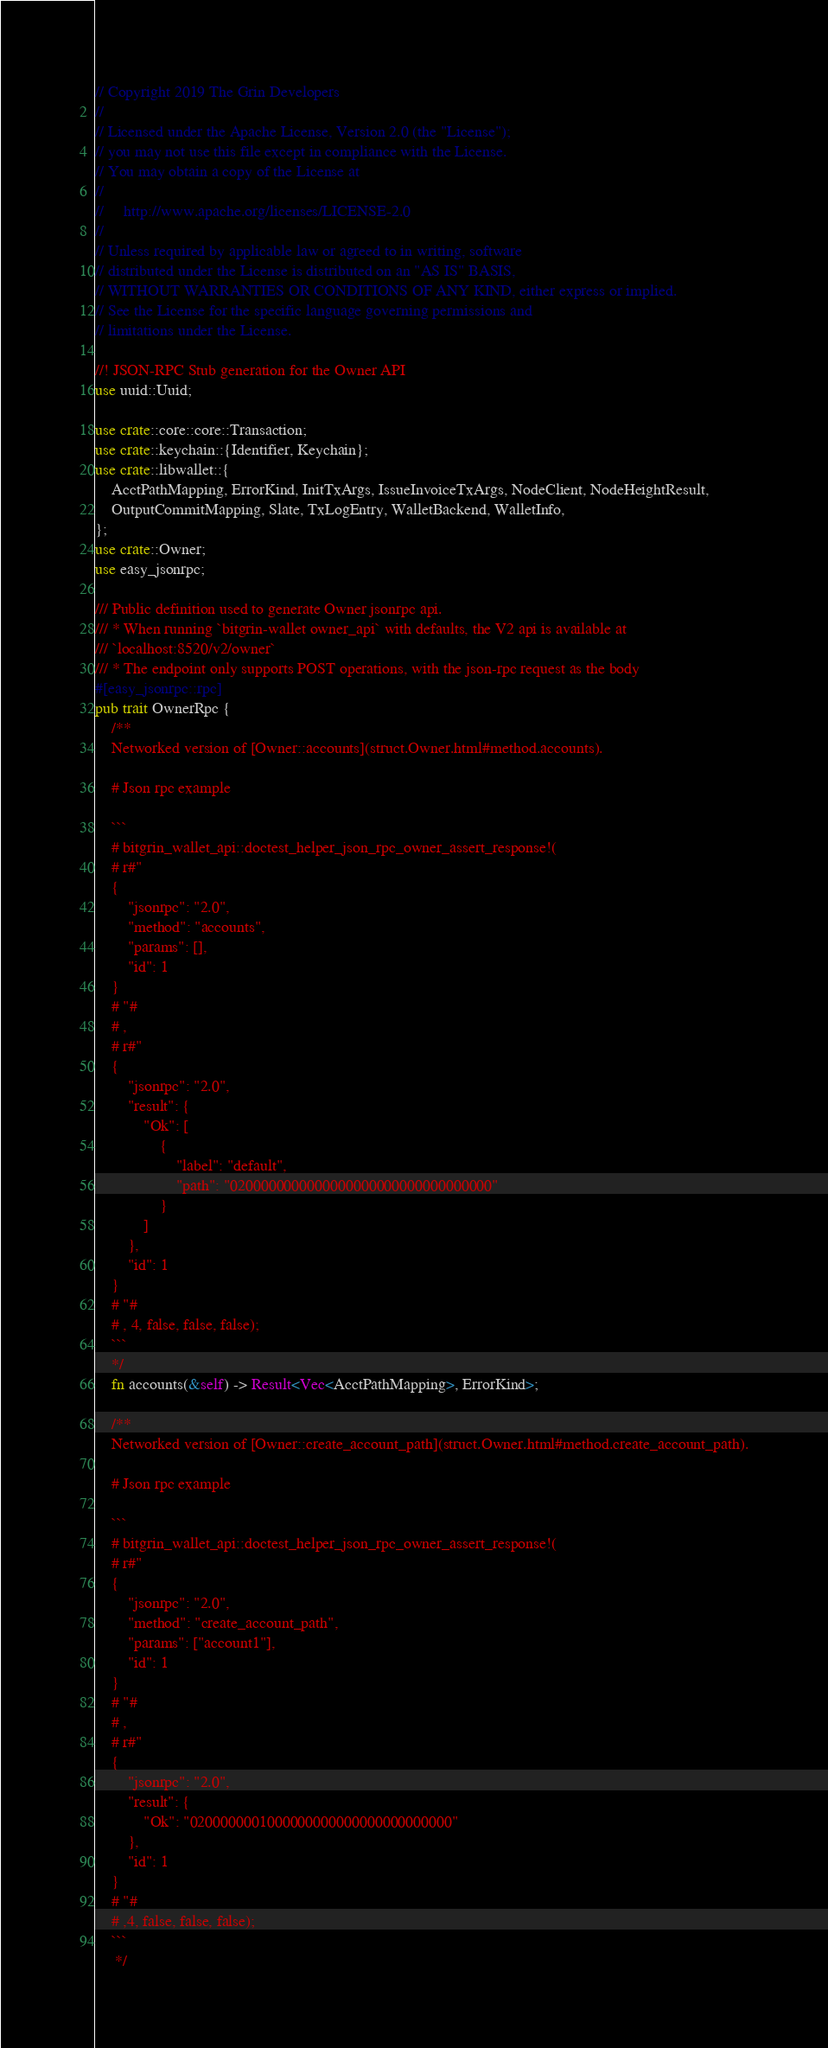<code> <loc_0><loc_0><loc_500><loc_500><_Rust_>// Copyright 2019 The Grin Developers
//
// Licensed under the Apache License, Version 2.0 (the "License");
// you may not use this file except in compliance with the License.
// You may obtain a copy of the License at
//
//     http://www.apache.org/licenses/LICENSE-2.0
//
// Unless required by applicable law or agreed to in writing, software
// distributed under the License is distributed on an "AS IS" BASIS,
// WITHOUT WARRANTIES OR CONDITIONS OF ANY KIND, either express or implied.
// See the License for the specific language governing permissions and
// limitations under the License.

//! JSON-RPC Stub generation for the Owner API
use uuid::Uuid;

use crate::core::core::Transaction;
use crate::keychain::{Identifier, Keychain};
use crate::libwallet::{
	AcctPathMapping, ErrorKind, InitTxArgs, IssueInvoiceTxArgs, NodeClient, NodeHeightResult,
	OutputCommitMapping, Slate, TxLogEntry, WalletBackend, WalletInfo,
};
use crate::Owner;
use easy_jsonrpc;

/// Public definition used to generate Owner jsonrpc api.
/// * When running `bitgrin-wallet owner_api` with defaults, the V2 api is available at
/// `localhost:8520/v2/owner`
/// * The endpoint only supports POST operations, with the json-rpc request as the body
#[easy_jsonrpc::rpc]
pub trait OwnerRpc {
	/**
	Networked version of [Owner::accounts](struct.Owner.html#method.accounts).

	# Json rpc example

	```
	# bitgrin_wallet_api::doctest_helper_json_rpc_owner_assert_response!(
	# r#"
	{
		"jsonrpc": "2.0",
		"method": "accounts",
		"params": [],
		"id": 1
	}
	# "#
	# ,
	# r#"
	{
		"jsonrpc": "2.0",
		"result": {
			"Ok": [
				{
					"label": "default",
					"path": "0200000000000000000000000000000000"
				}
			]
		},
		"id": 1
	}
	# "#
	# , 4, false, false, false);
	```
	*/
	fn accounts(&self) -> Result<Vec<AcctPathMapping>, ErrorKind>;

	/**
	Networked version of [Owner::create_account_path](struct.Owner.html#method.create_account_path).

	# Json rpc example

	```
	# bitgrin_wallet_api::doctest_helper_json_rpc_owner_assert_response!(
	# r#"
	{
		"jsonrpc": "2.0",
		"method": "create_account_path",
		"params": ["account1"],
		"id": 1
	}
	# "#
	# ,
	# r#"
	{
		"jsonrpc": "2.0",
		"result": {
			"Ok": "0200000001000000000000000000000000"
		},
		"id": 1
	}
	# "#
	# ,4, false, false, false);
	```
	 */</code> 